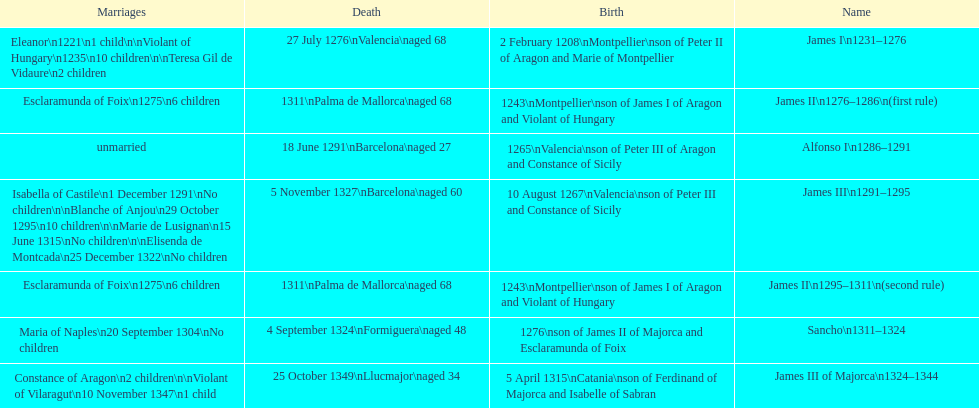James i and james ii both died at what age? 68. 